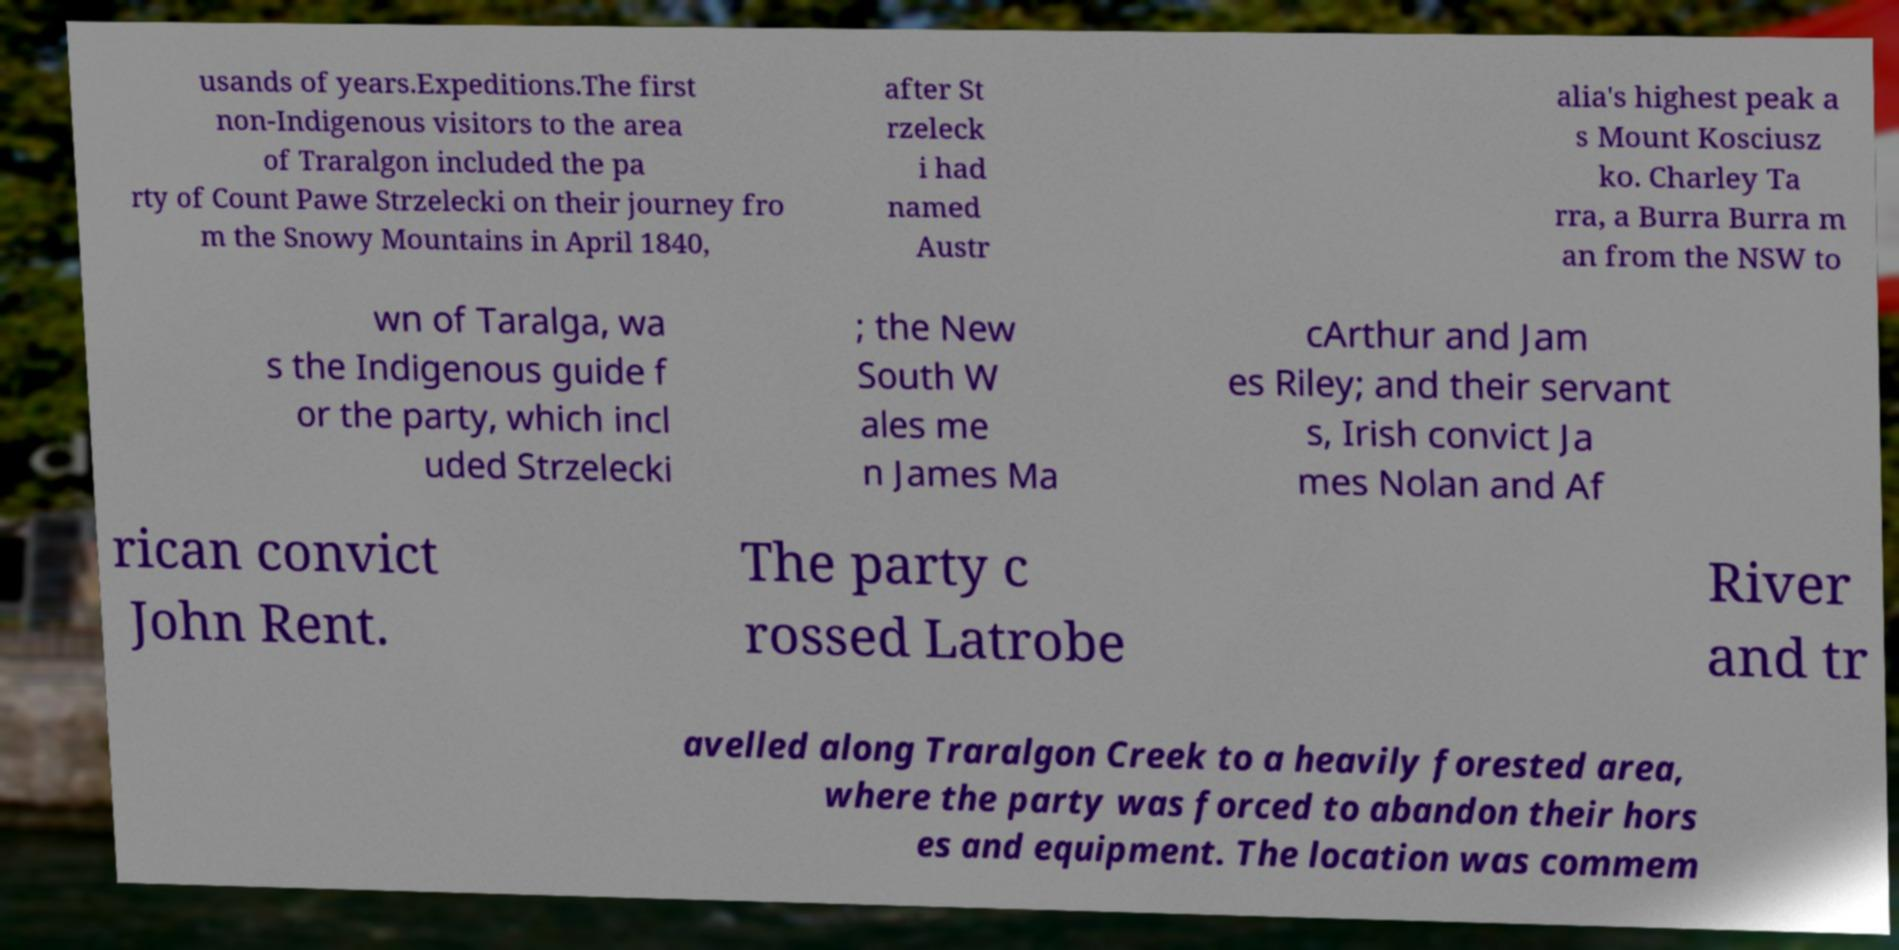Please read and relay the text visible in this image. What does it say? usands of years.Expeditions.The first non-Indigenous visitors to the area of Traralgon included the pa rty of Count Pawe Strzelecki on their journey fro m the Snowy Mountains in April 1840, after St rzeleck i had named Austr alia's highest peak a s Mount Kosciusz ko. Charley Ta rra, a Burra Burra m an from the NSW to wn of Taralga, wa s the Indigenous guide f or the party, which incl uded Strzelecki ; the New South W ales me n James Ma cArthur and Jam es Riley; and their servant s, Irish convict Ja mes Nolan and Af rican convict John Rent. The party c rossed Latrobe River and tr avelled along Traralgon Creek to a heavily forested area, where the party was forced to abandon their hors es and equipment. The location was commem 